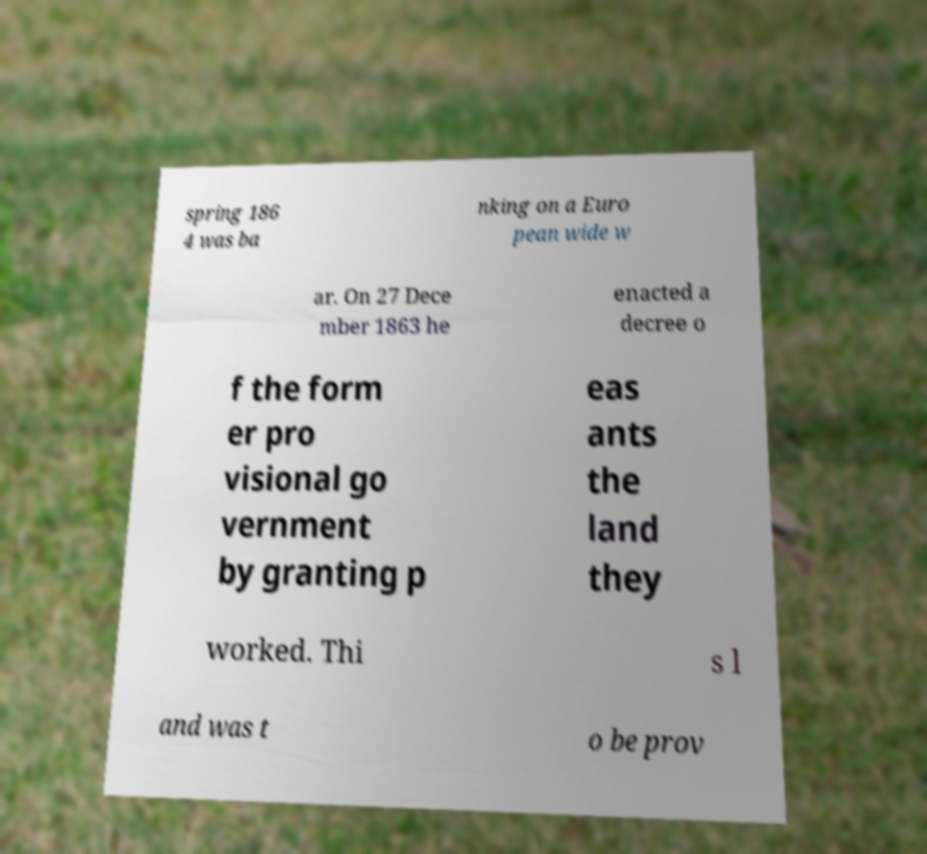Please identify and transcribe the text found in this image. spring 186 4 was ba nking on a Euro pean wide w ar. On 27 Dece mber 1863 he enacted a decree o f the form er pro visional go vernment by granting p eas ants the land they worked. Thi s l and was t o be prov 